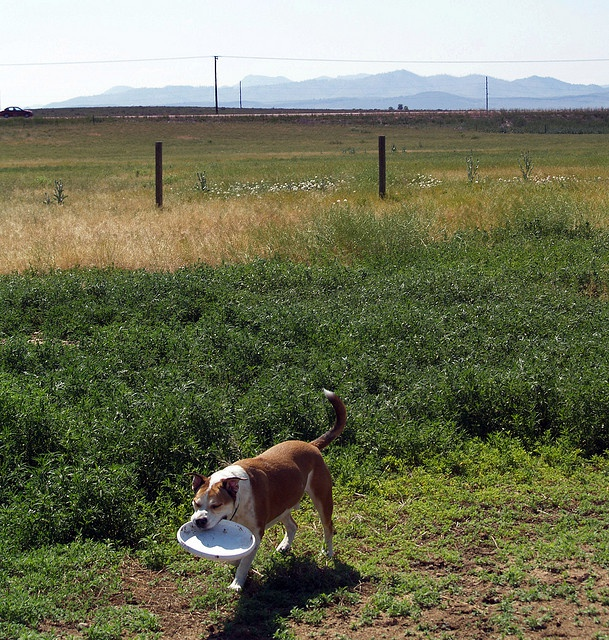Describe the objects in this image and their specific colors. I can see dog in white, black, gray, and maroon tones, frisbee in white and gray tones, and car in white, black, navy, lightblue, and darkblue tones in this image. 